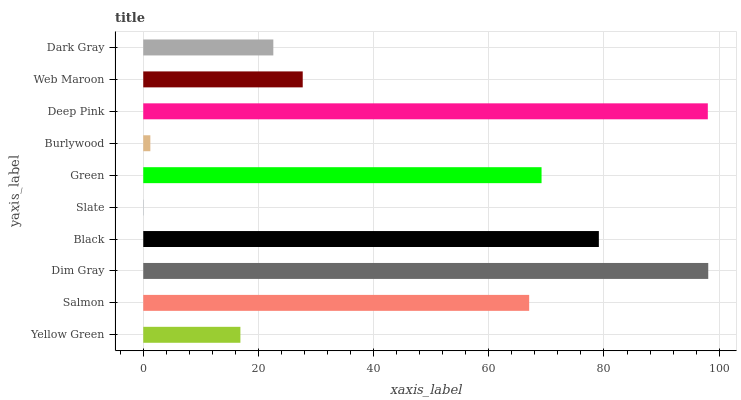Is Slate the minimum?
Answer yes or no. Yes. Is Dim Gray the maximum?
Answer yes or no. Yes. Is Salmon the minimum?
Answer yes or no. No. Is Salmon the maximum?
Answer yes or no. No. Is Salmon greater than Yellow Green?
Answer yes or no. Yes. Is Yellow Green less than Salmon?
Answer yes or no. Yes. Is Yellow Green greater than Salmon?
Answer yes or no. No. Is Salmon less than Yellow Green?
Answer yes or no. No. Is Salmon the high median?
Answer yes or no. Yes. Is Web Maroon the low median?
Answer yes or no. Yes. Is Burlywood the high median?
Answer yes or no. No. Is Dark Gray the low median?
Answer yes or no. No. 